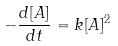<formula> <loc_0><loc_0><loc_500><loc_500>- \frac { d [ A ] } { d t } = k [ A ] ^ { 2 }</formula> 